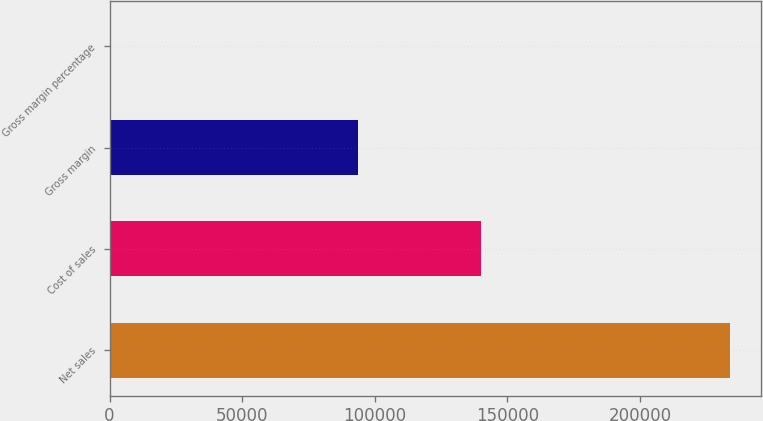Convert chart to OTSL. <chart><loc_0><loc_0><loc_500><loc_500><bar_chart><fcel>Net sales<fcel>Cost of sales<fcel>Gross margin<fcel>Gross margin percentage<nl><fcel>233715<fcel>140089<fcel>93626<fcel>40.1<nl></chart> 